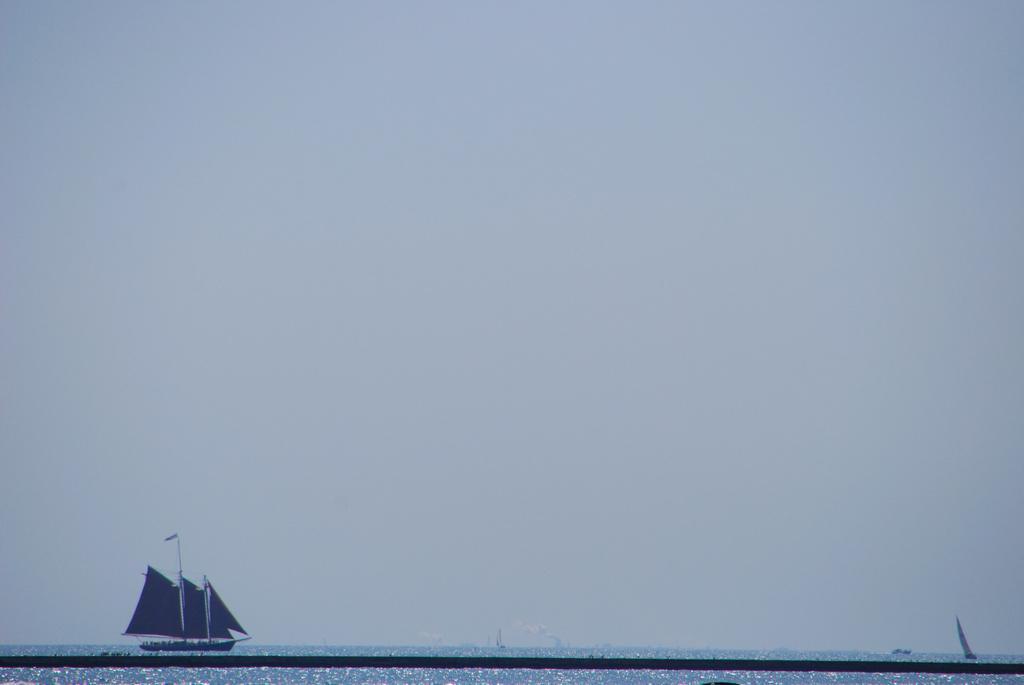Describe this image in one or two sentences. This image consists of a boat. At the bottom, there is water. At the top, there is sky. 